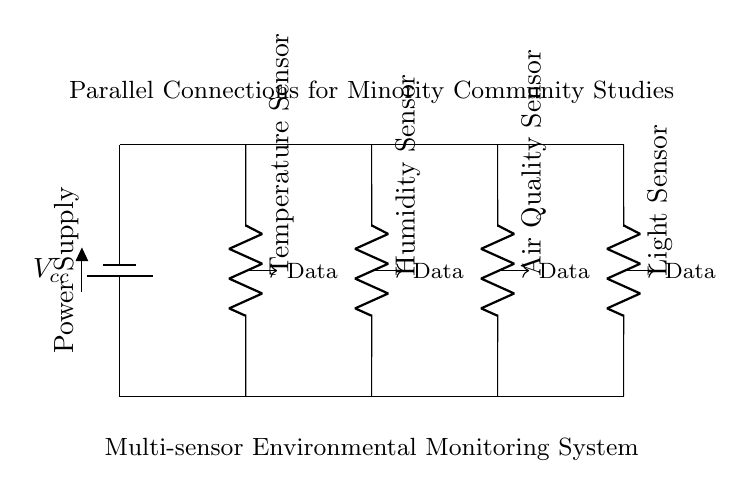What is the purpose of the battery in this circuit? The battery provides the necessary power supply to the entire circuit. It connects at the top, supplying voltage to the sensors, enabling them to operate.
Answer: Power supply How many sensors are in this system? There are four sensors connected in parallel to the power supply, as illustrated in the circuit diagram.
Answer: Four What type of connection is used in this circuit? The circuit utilizes parallel connections, meaning each sensor is connected across the same voltage source and operates independently.
Answer: Parallel Which sensor is placed farthest to the right? The light sensor is located at the far right end of the circuit diagram, indicating its position in the arrangement.
Answer: Light sensor What happens to the current through each sensor in a parallel configuration? In a parallel configuration, the total current splits among the sensors, allowing each to draw its required current independently from the same voltage source.
Answer: Splits What is the voltage across each sensor? Since the sensors are in parallel, they all receive the same voltage as supplied by the battery, indicated at the top of the circuit.
Answer: Same as battery voltage What is the layout of the sensor connections? The sensors are arranged vertically in a straight line, with each connected between the top (voltage) and bottom (ground) rails.
Answer: Vertical arrangement 